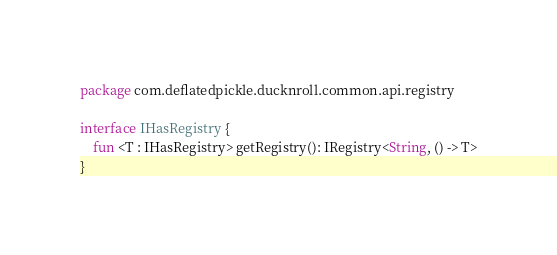<code> <loc_0><loc_0><loc_500><loc_500><_Kotlin_>package com.deflatedpickle.ducknroll.common.api.registry

interface IHasRegistry {
    fun <T : IHasRegistry> getRegistry(): IRegistry<String, () -> T>
}</code> 